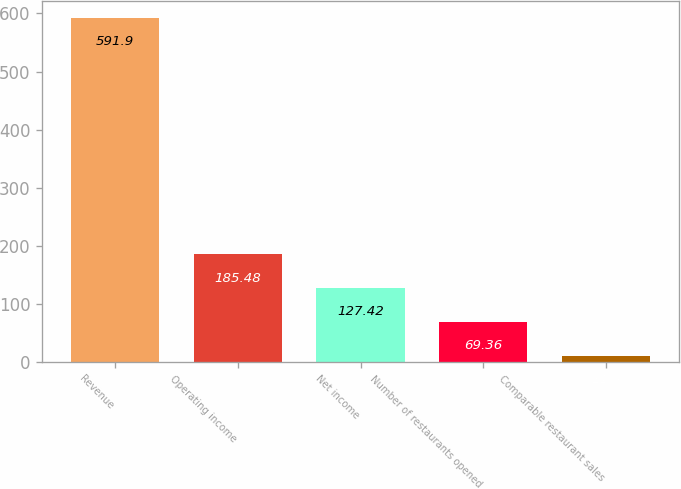Convert chart. <chart><loc_0><loc_0><loc_500><loc_500><bar_chart><fcel>Revenue<fcel>Operating income<fcel>Net income<fcel>Number of restaurants opened<fcel>Comparable restaurant sales<nl><fcel>591.9<fcel>185.48<fcel>127.42<fcel>69.36<fcel>11.3<nl></chart> 